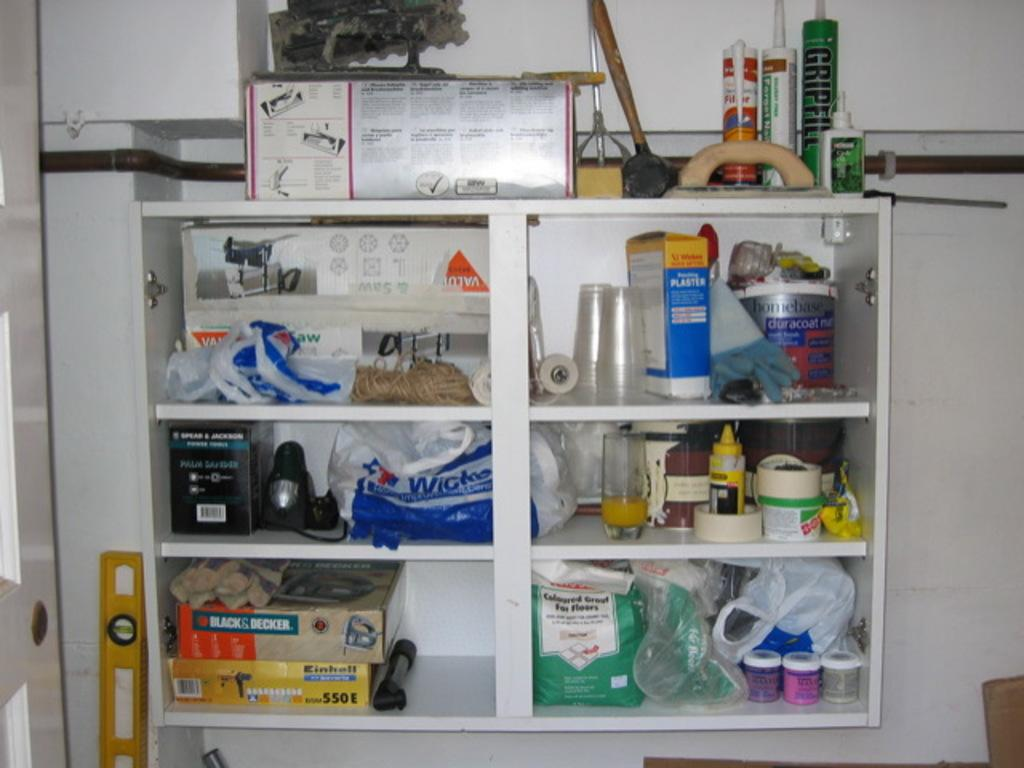Provide a one-sentence caption for the provided image. A storage space filled with cups and boxes, with one large box listed as a Black and Decker equipment. 